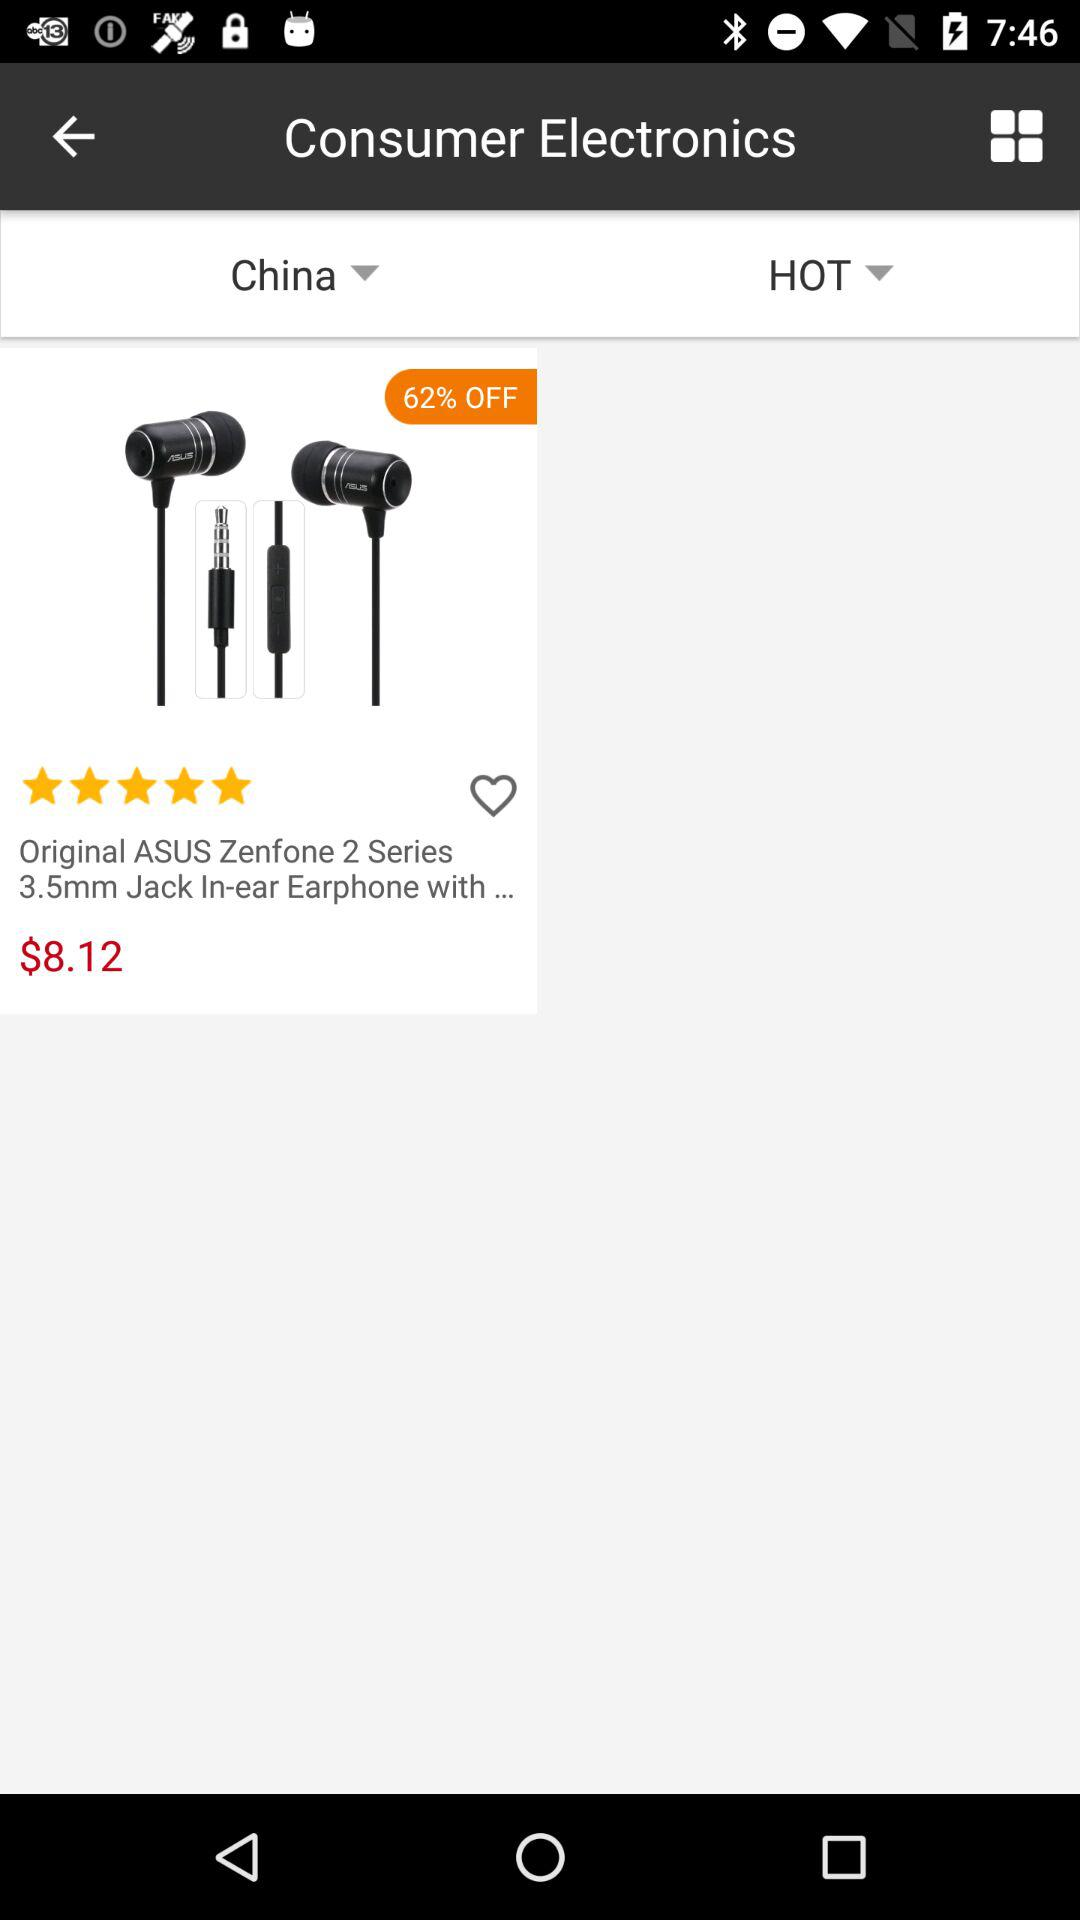How much is off on the headphones? There is 62 percent off on the headphones. 